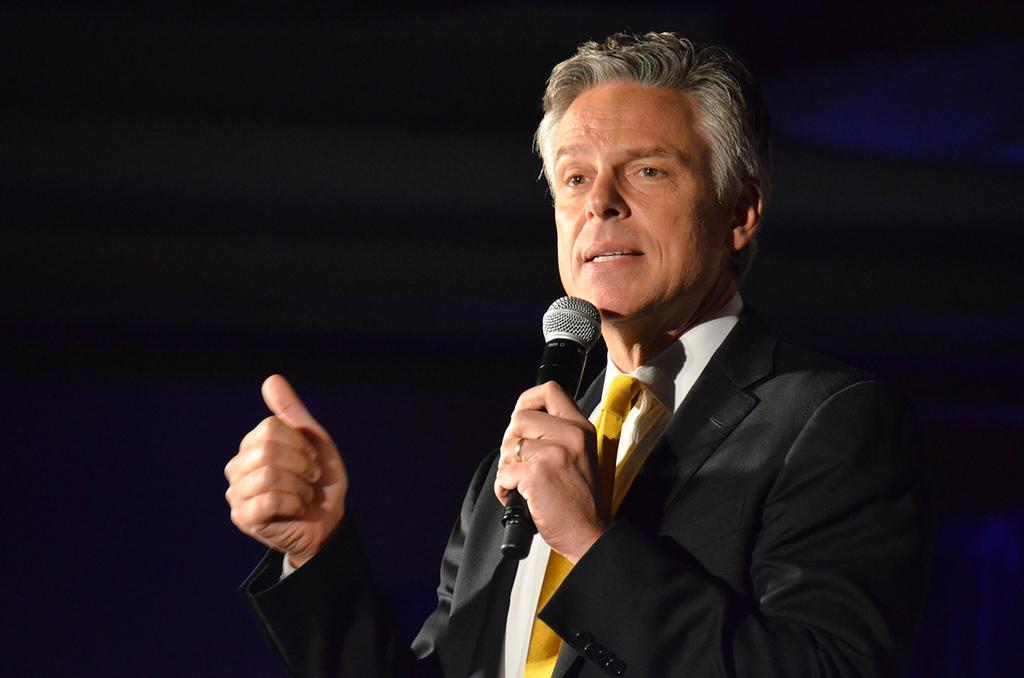How would you summarize this image in a sentence or two? In this picture, In the right side there is a man standing and he is holding a microphone which is in black color and he is talking something in microphone and in the left side there is a hand and he is showing thumb. 